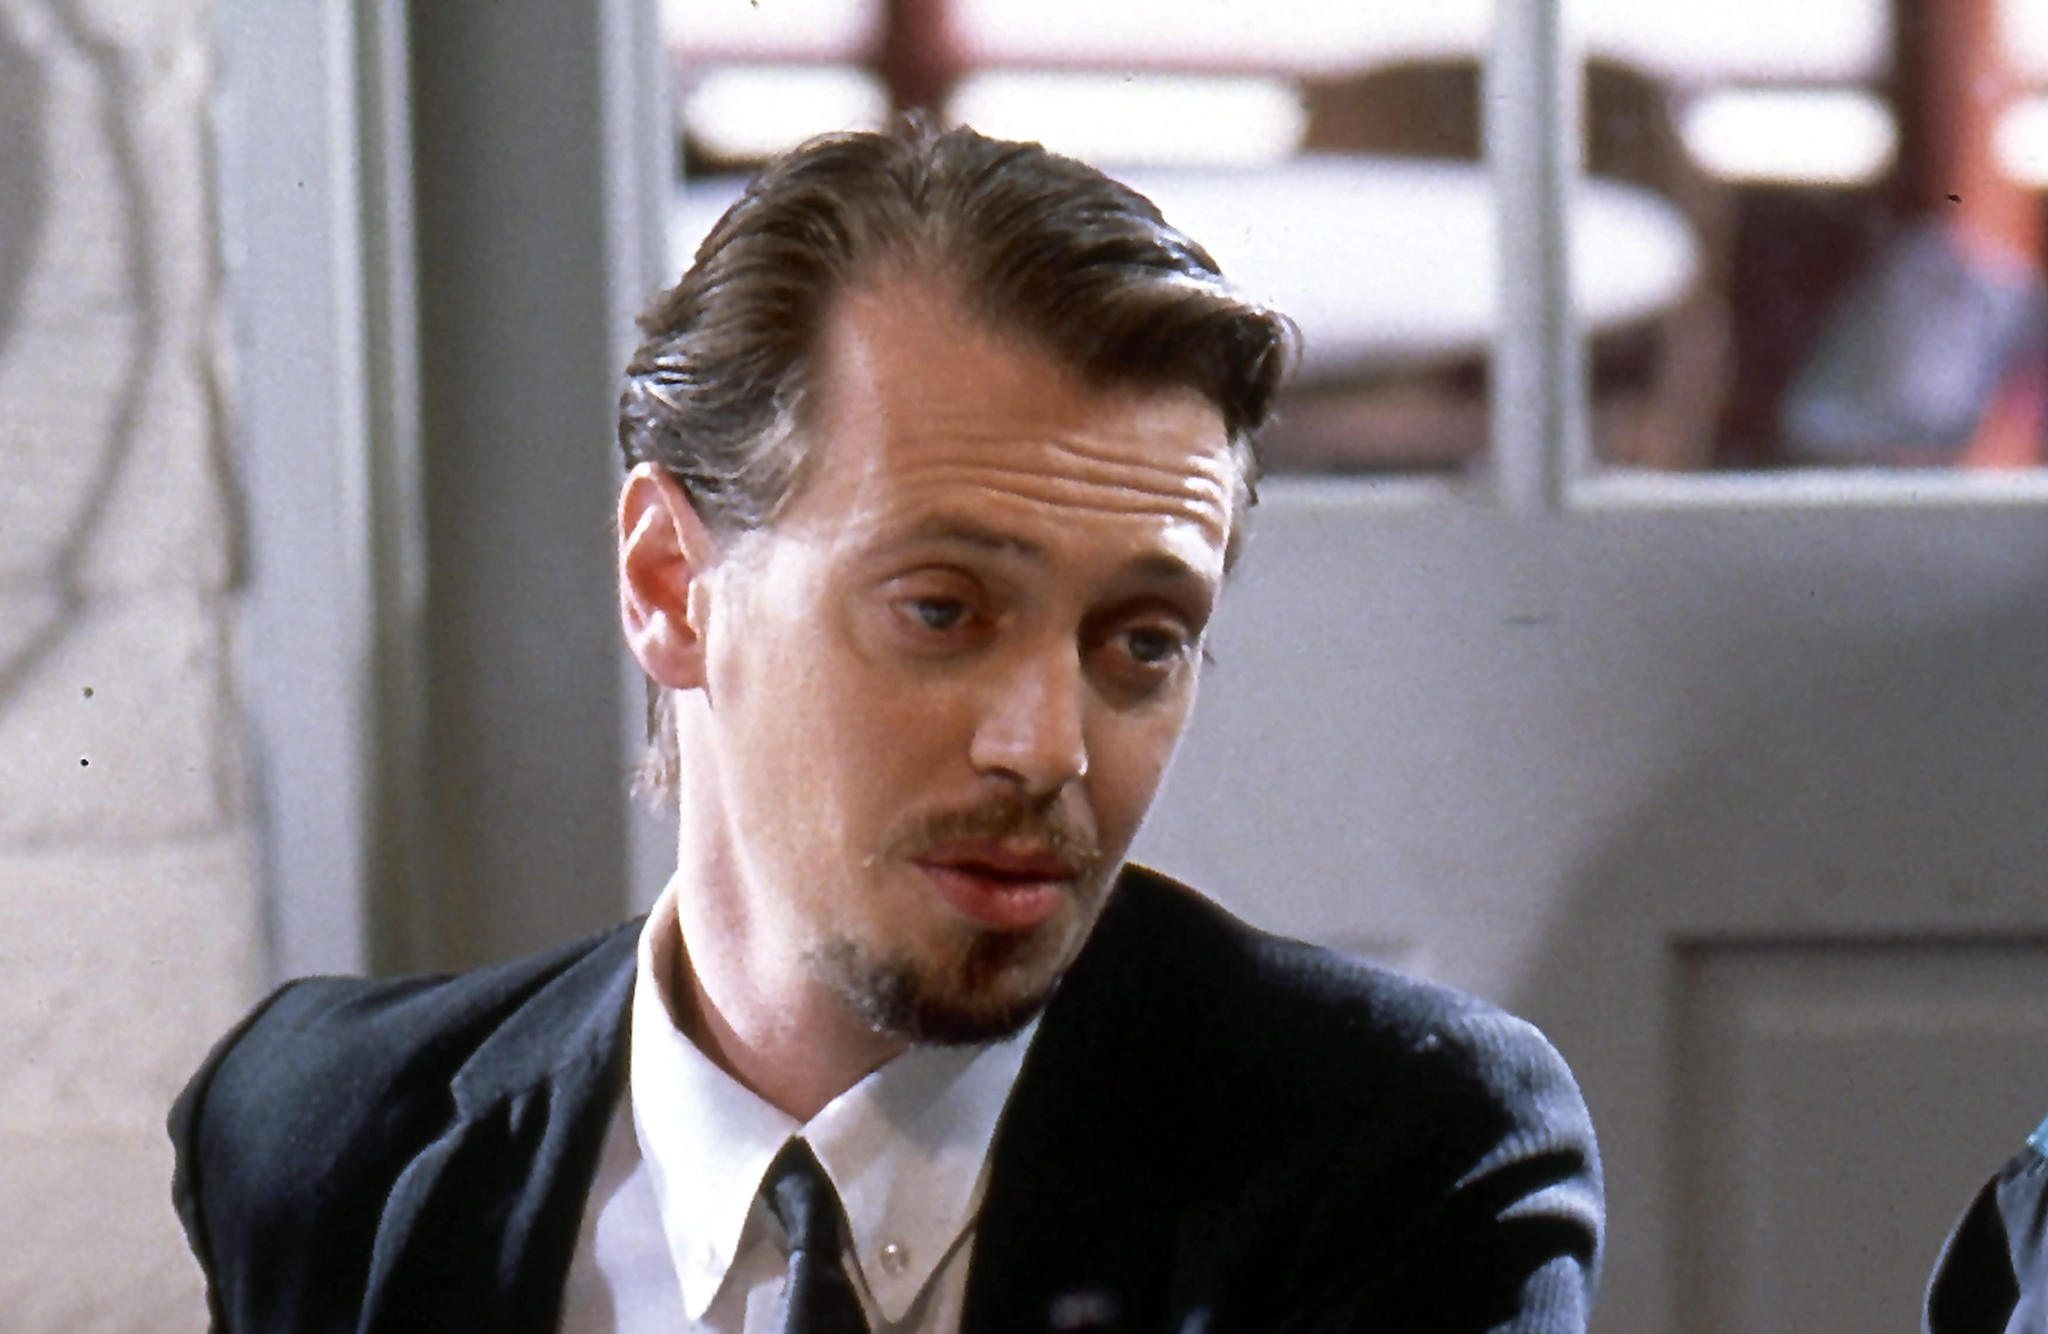Imagine the character in this image is preparing for a secret mission. Write a detailed account of what he might be thinking. As Mr. Pink, portrayed by Steve Buscemi, sits quietly in the dimly lit café, his mind races with the details of the secret mission he is about to undertake. His formal attire gives nothing away about the gravity of his thoughts. He silently reviews the plan in his head, considering each movement, each decision he will need to make. There's a mixture of anticipation and trepidation in his eyes as he visualizes the high-stakes scenario. His fingers tap the table rhythmically, reflecting the urgency and hidden tension beneath his calm exterior. He knows that every move will count, and the success or failure of this mission rests squarely on his shoulders. The weight of responsibility hangs heavily in the air, blending with the faint aroma of coffee and distant chatter, anchoring him to the reality of the moment. 